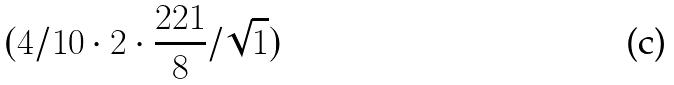Convert formula to latex. <formula><loc_0><loc_0><loc_500><loc_500>( 4 / 1 0 \cdot 2 \cdot \frac { 2 2 1 } { 8 } / \sqrt { 1 } )</formula> 